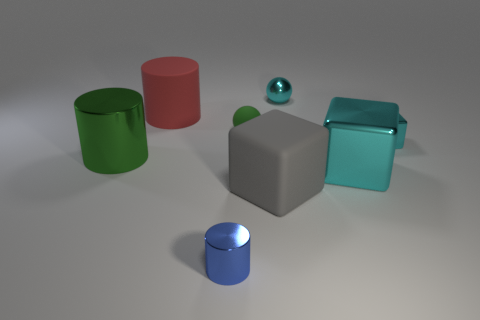Subtract all shiny blocks. How many blocks are left? 1 Add 1 metallic cylinders. How many objects exist? 9 Subtract all green cylinders. How many cylinders are left? 2 Subtract 2 balls. How many balls are left? 0 Subtract all balls. How many objects are left? 6 Subtract all purple spheres. How many blue cylinders are left? 1 Add 6 red rubber things. How many red rubber things exist? 7 Subtract 0 yellow blocks. How many objects are left? 8 Subtract all purple spheres. Subtract all brown cylinders. How many spheres are left? 2 Subtract all large red cylinders. Subtract all gray rubber cubes. How many objects are left? 6 